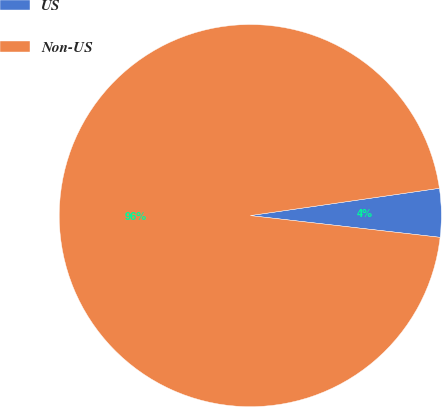<chart> <loc_0><loc_0><loc_500><loc_500><pie_chart><fcel>US<fcel>Non-US<nl><fcel>4.1%<fcel>95.9%<nl></chart> 